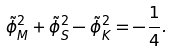Convert formula to latex. <formula><loc_0><loc_0><loc_500><loc_500>\tilde { \phi } ^ { 2 } _ { M } + \tilde { \phi } ^ { 2 } _ { S } - \tilde { \phi } ^ { 2 } _ { K } = - \frac { 1 } { 4 } .</formula> 